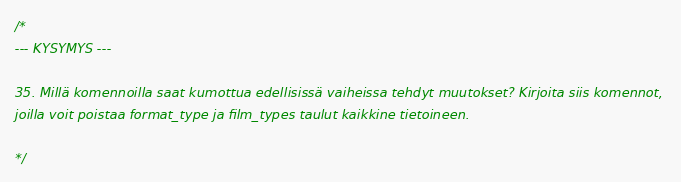Convert code to text. <code><loc_0><loc_0><loc_500><loc_500><_SQL_>/*
--- KYSYMYS ---

35. Millä komennoilla saat kumottua edellisissä vaiheissa tehdyt muutokset? Kirjoita siis komennot, 
joilla voit poistaa format_type ja film_types taulut kaikkine tietoineen.

*/</code> 